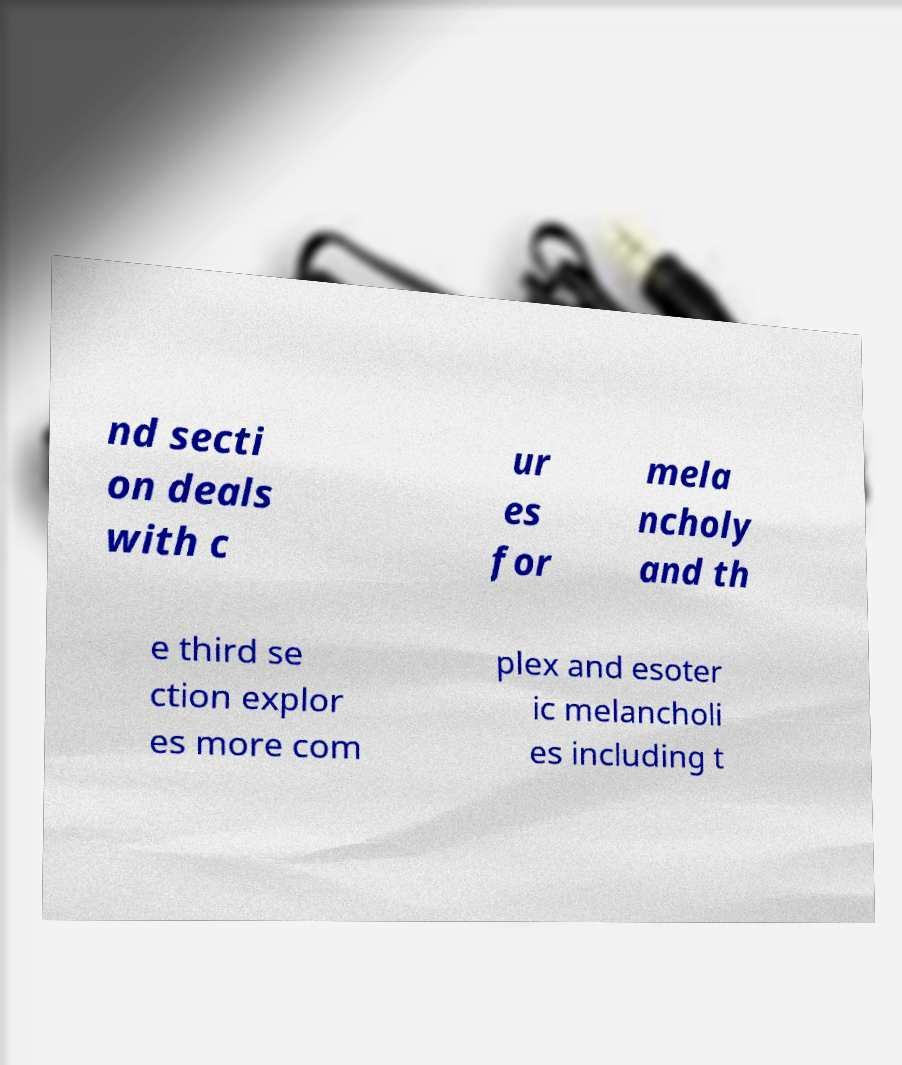For documentation purposes, I need the text within this image transcribed. Could you provide that? nd secti on deals with c ur es for mela ncholy and th e third se ction explor es more com plex and esoter ic melancholi es including t 